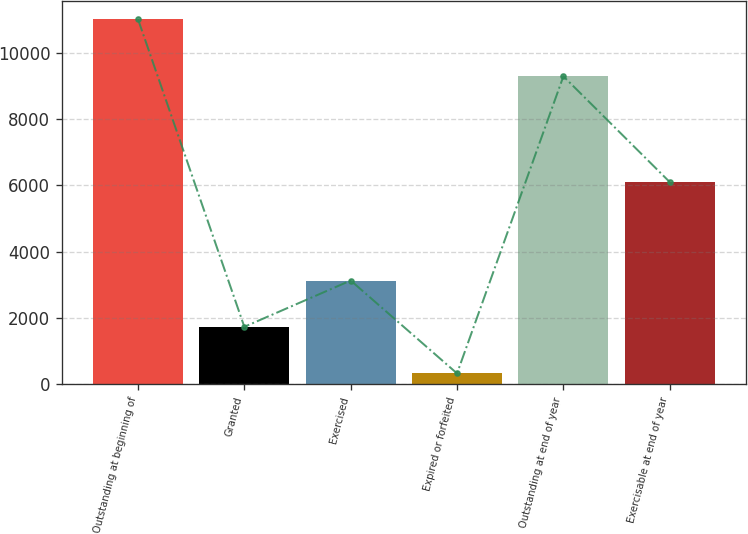Convert chart to OTSL. <chart><loc_0><loc_0><loc_500><loc_500><bar_chart><fcel>Outstanding at beginning of<fcel>Granted<fcel>Exercised<fcel>Expired or forfeited<fcel>Outstanding at end of year<fcel>Exercisable at end of year<nl><fcel>11004<fcel>1730<fcel>3126<fcel>325<fcel>9283<fcel>6094<nl></chart> 